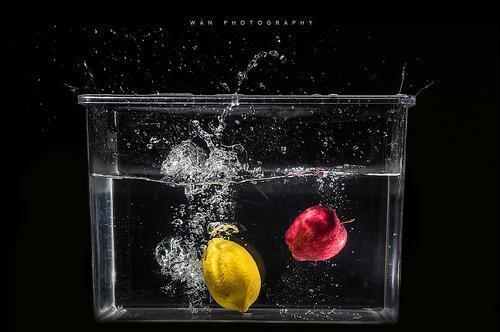How many fruits are in this photo?
Give a very brief answer. 2. How many apples are visible?
Give a very brief answer. 1. 